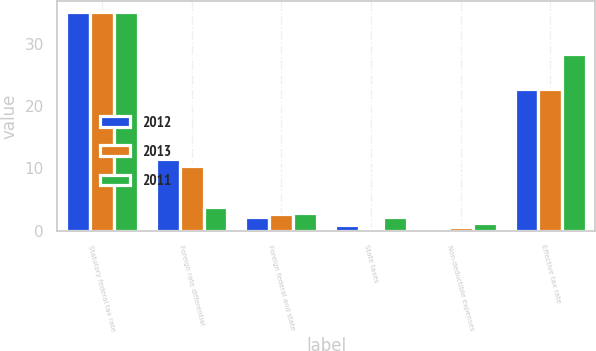Convert chart. <chart><loc_0><loc_0><loc_500><loc_500><stacked_bar_chart><ecel><fcel>Statutory federal tax rate<fcel>Foreign rate differential<fcel>Foreign federal and state<fcel>State taxes<fcel>Non-deductible expenses<fcel>Effective tax rate<nl><fcel>2012<fcel>35<fcel>11.6<fcel>2.2<fcel>1<fcel>0.5<fcel>22.7<nl><fcel>2013<fcel>35<fcel>10.4<fcel>2.7<fcel>0.3<fcel>0.7<fcel>22.8<nl><fcel>2011<fcel>35<fcel>3.8<fcel>2.9<fcel>2.2<fcel>1.2<fcel>28.4<nl></chart> 